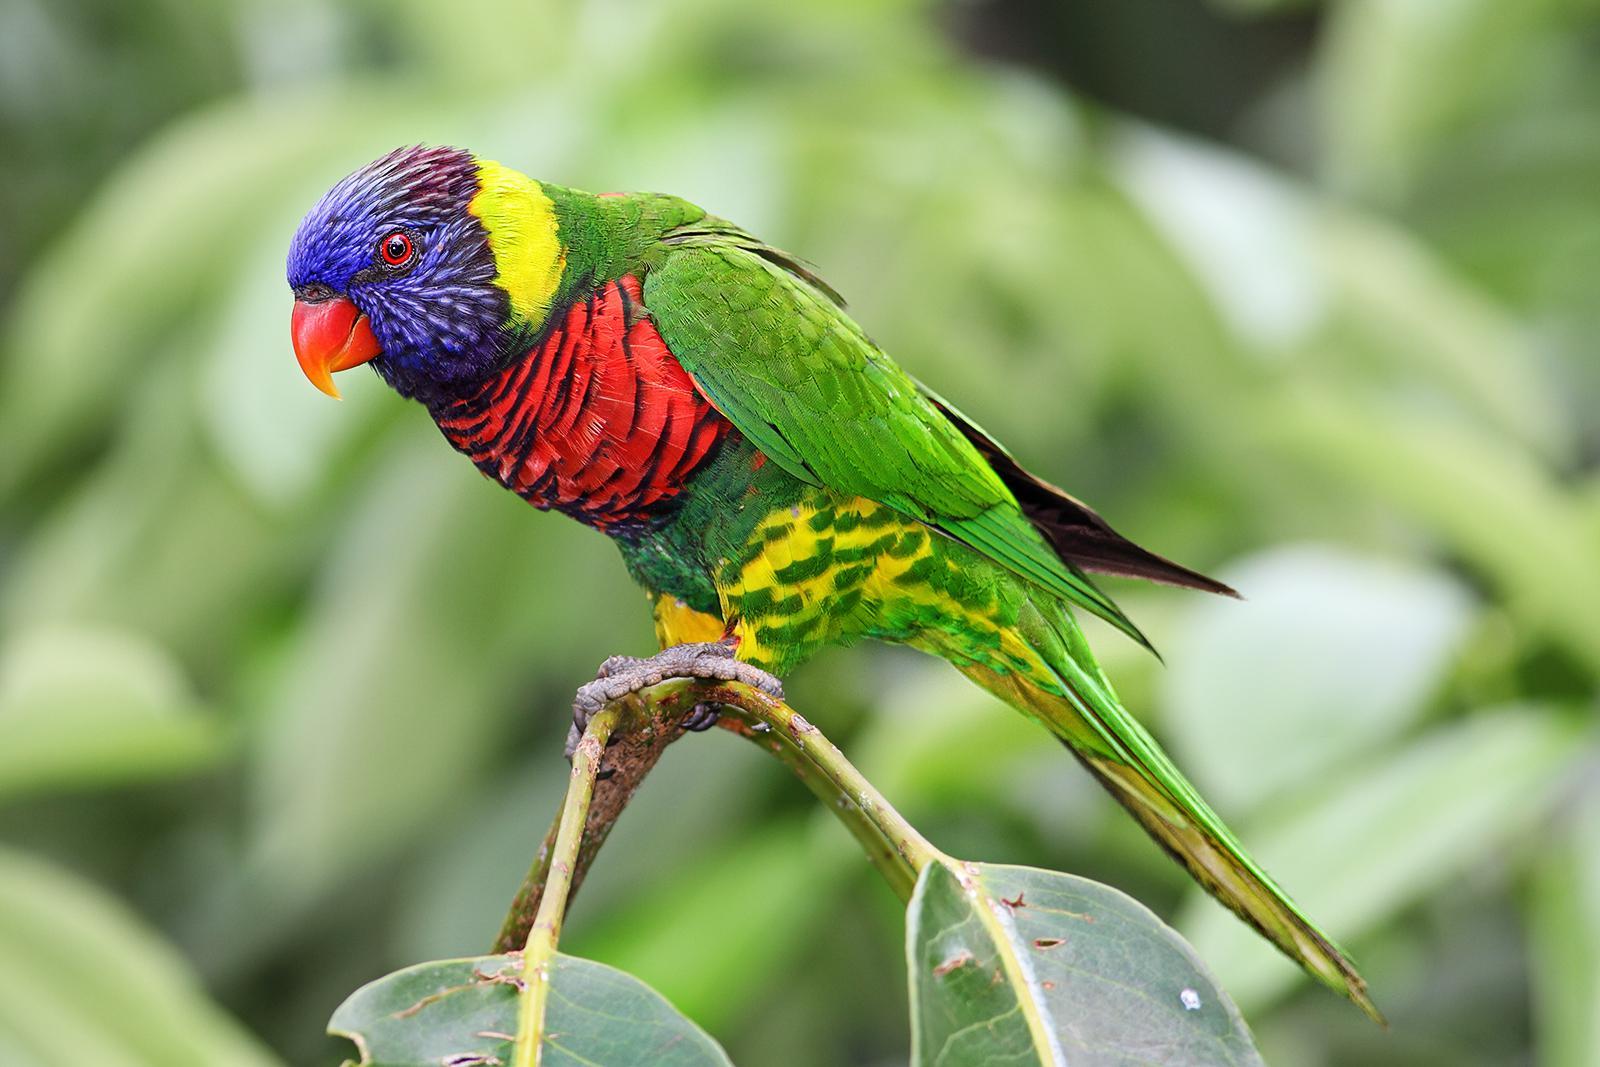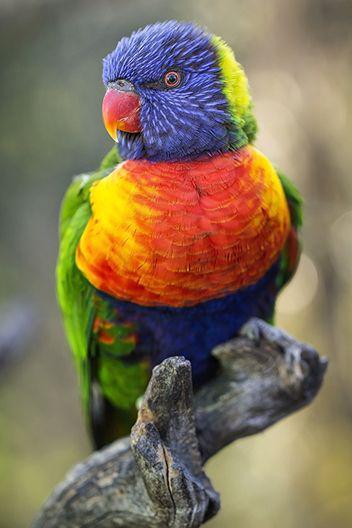The first image is the image on the left, the second image is the image on the right. Considering the images on both sides, is "At least one bird is facing towards the right side of the image." valid? Answer yes or no. No. The first image is the image on the left, the second image is the image on the right. Evaluate the accuracy of this statement regarding the images: "There are two birds in the image on the right.". Is it true? Answer yes or no. No. 